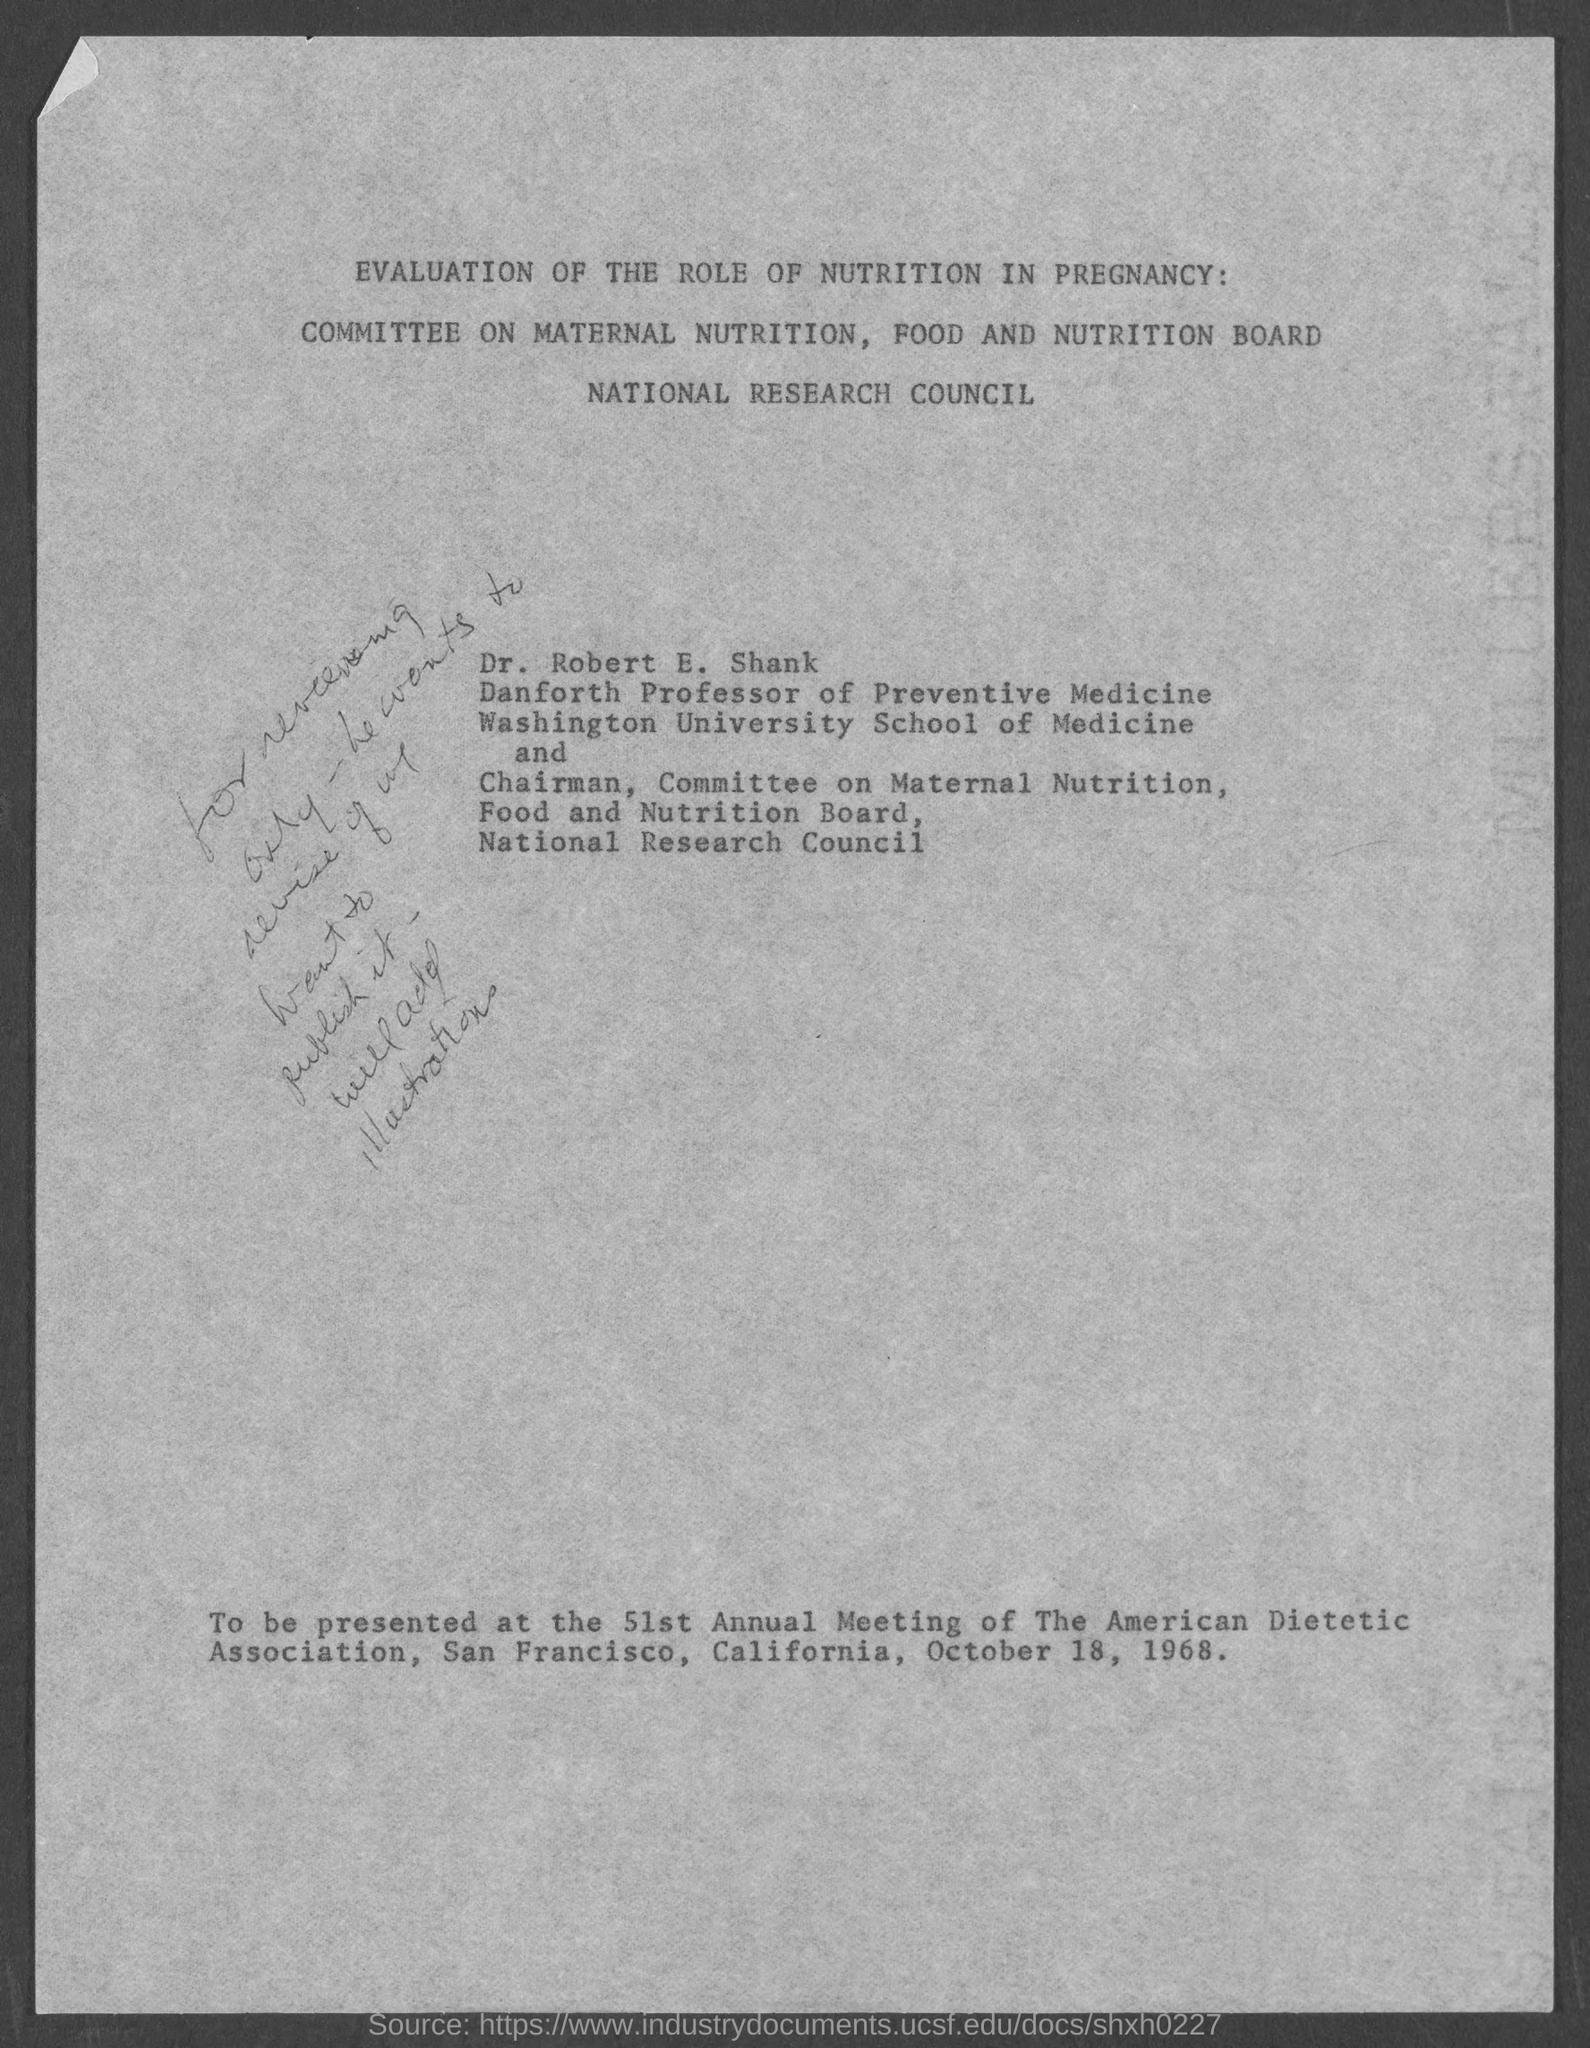List a handful of essential elements in this visual. The 51st annual meeting of the American Dietetic Association was held on October 18, 1968. 